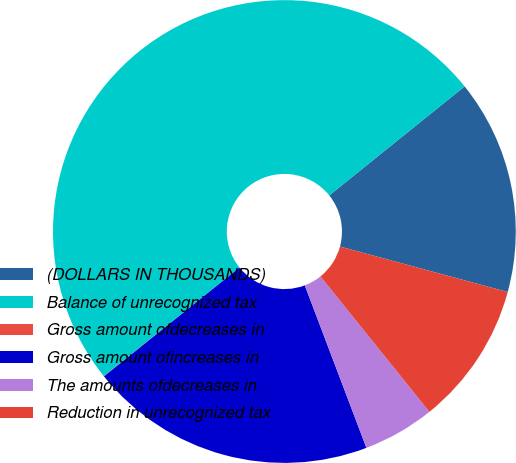<chart> <loc_0><loc_0><loc_500><loc_500><pie_chart><fcel>(DOLLARS IN THOUSANDS)<fcel>Balance of unrecognized tax<fcel>Gross amount ofdecreases in<fcel>Gross amount ofincreases in<fcel>The amounts ofdecreases in<fcel>Reduction in unrecognized tax<nl><fcel>15.0%<fcel>49.96%<fcel>0.02%<fcel>20.0%<fcel>5.01%<fcel>10.01%<nl></chart> 